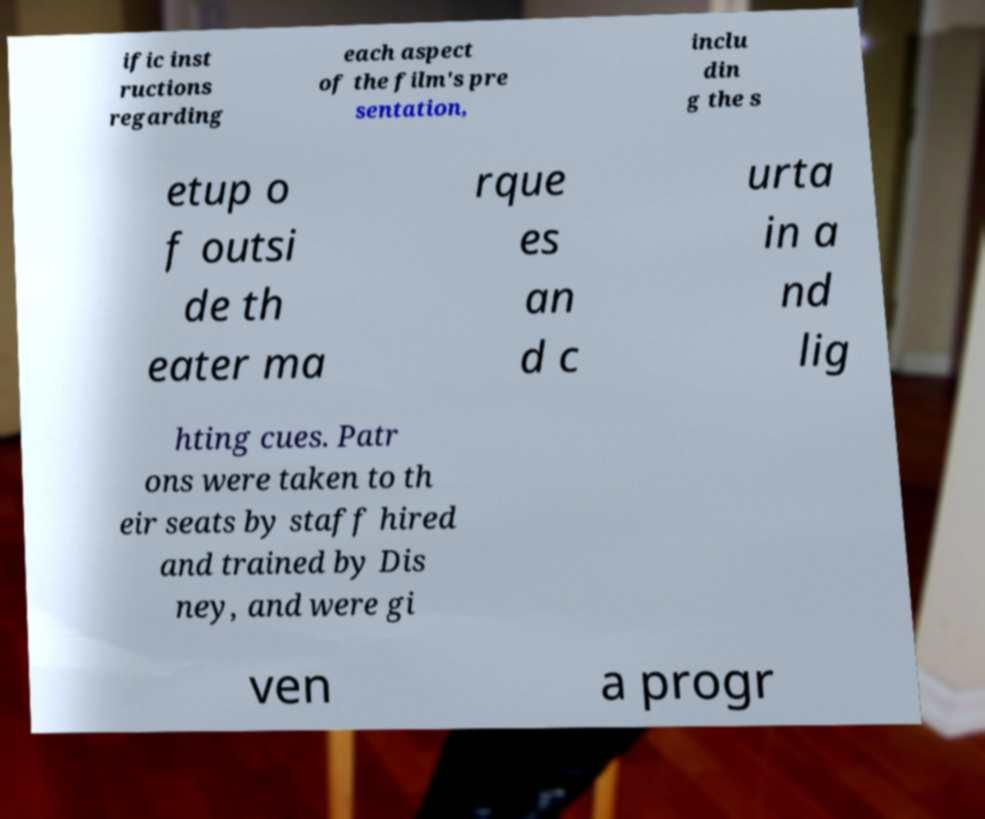Could you extract and type out the text from this image? ific inst ructions regarding each aspect of the film's pre sentation, inclu din g the s etup o f outsi de th eater ma rque es an d c urta in a nd lig hting cues. Patr ons were taken to th eir seats by staff hired and trained by Dis ney, and were gi ven a progr 